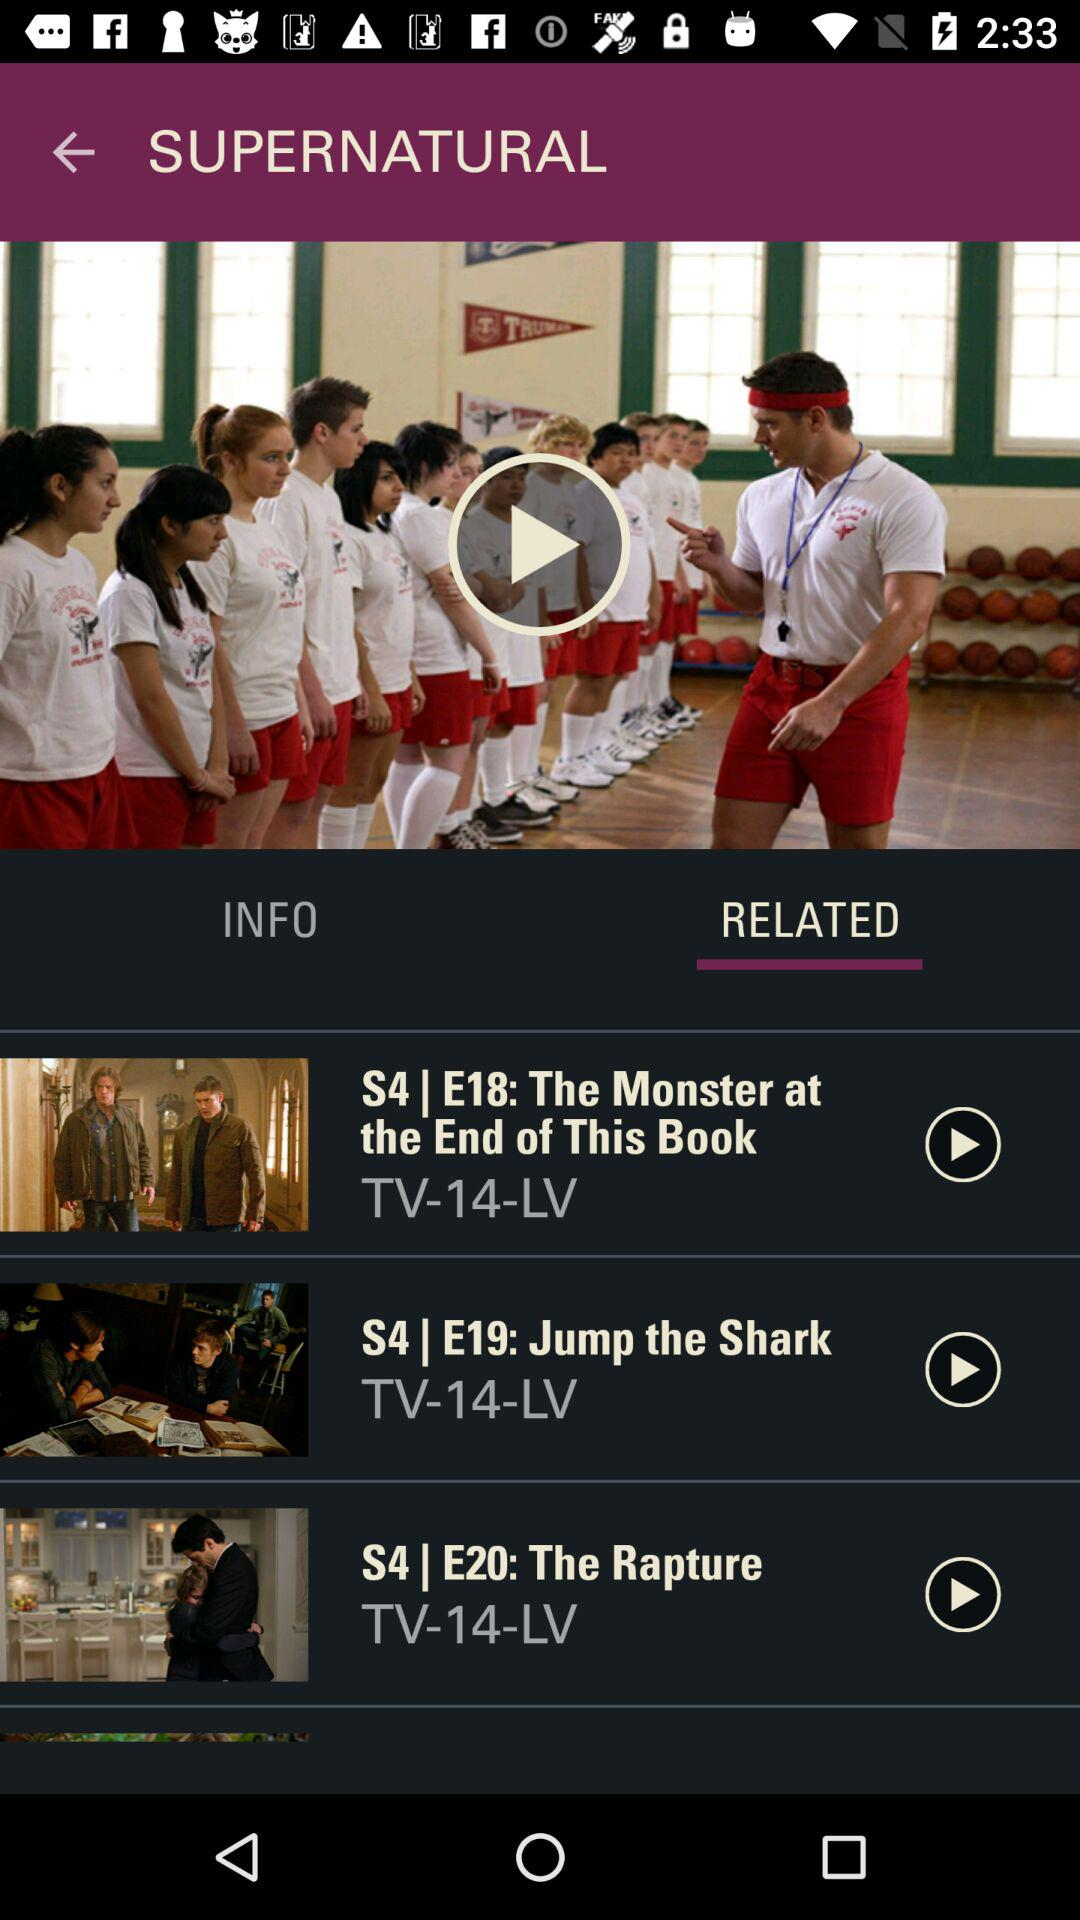What is the episode number of "Jump the Shark"? The episode number of "Jump the Shark" is 19. 